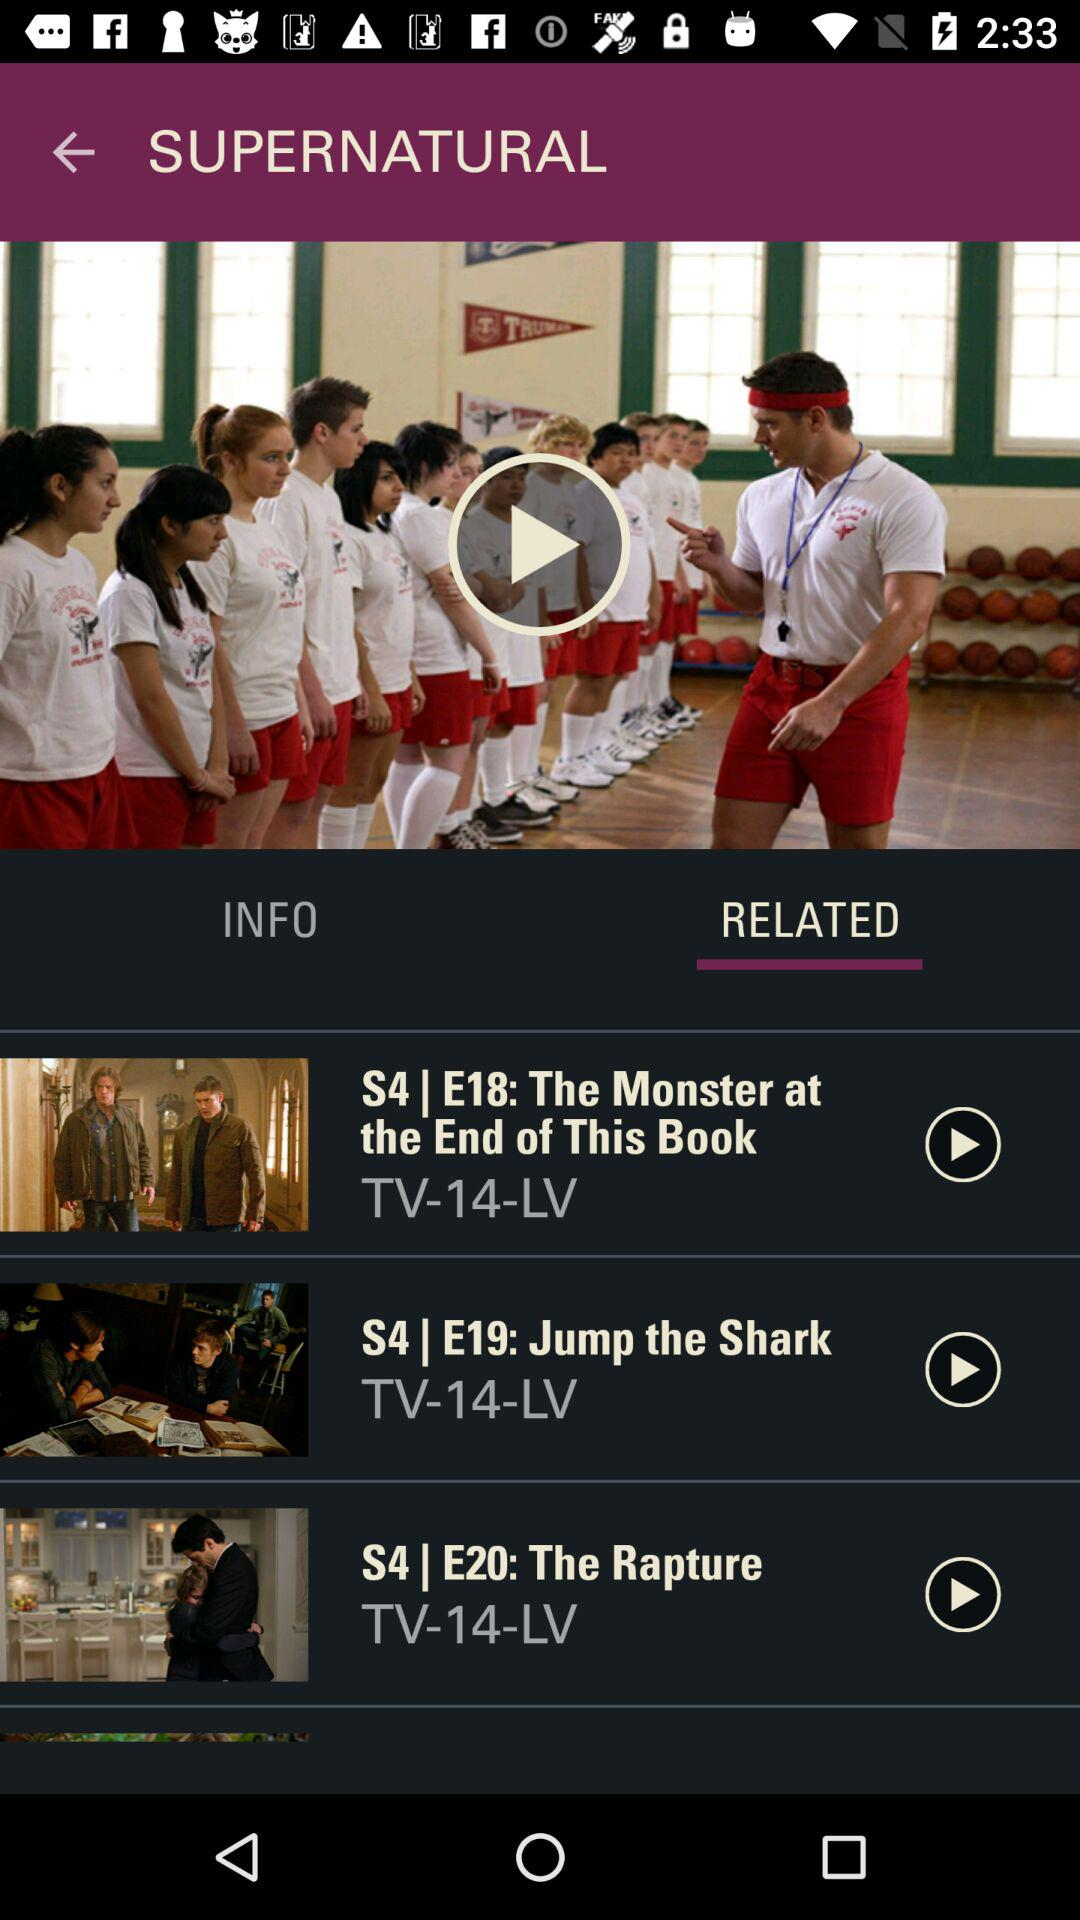What is the episode number of "Jump the Shark"? The episode number of "Jump the Shark" is 19. 